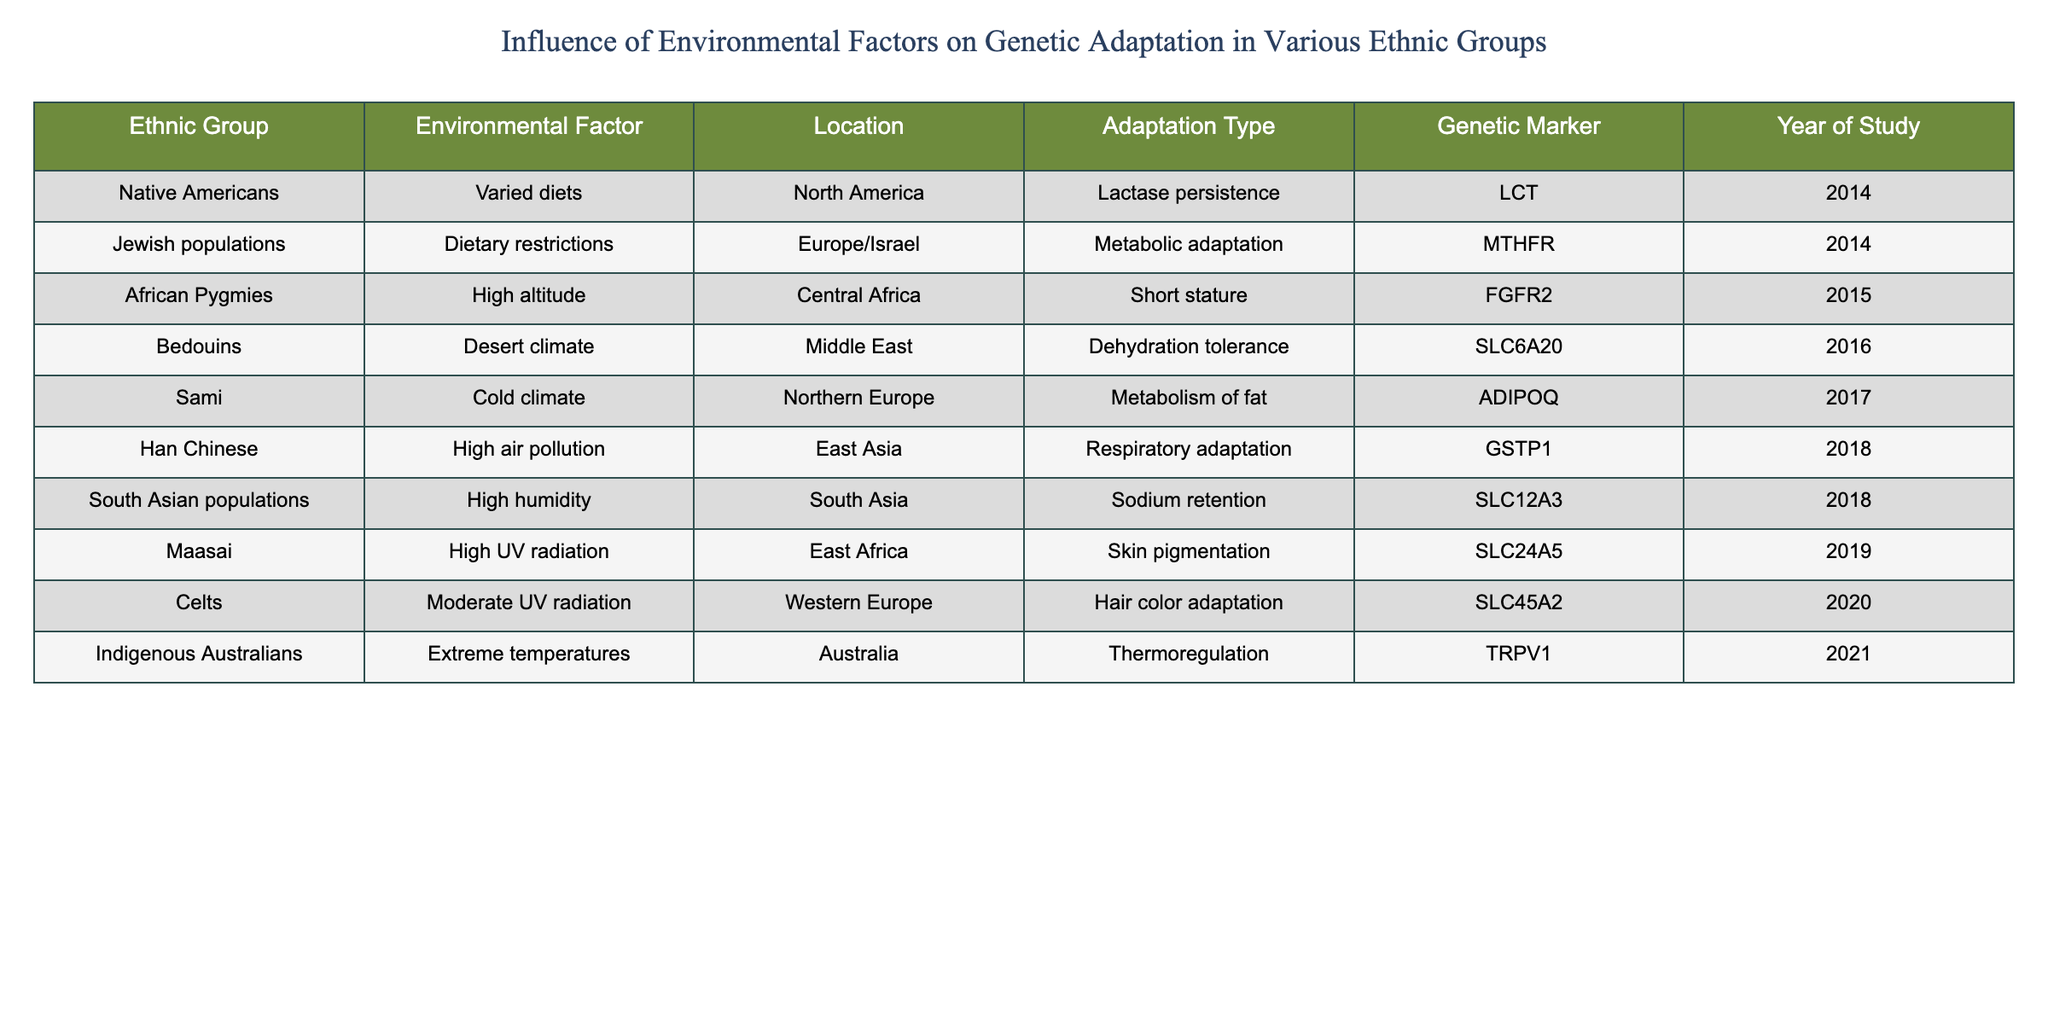What adaptation type is associated with African Pygmies? The table indicates that African Pygmies are associated with the adaptation type "Short stature." This information can be found in the row corresponding to the African Pygmies.
Answer: Short stature Which genetic marker is linked to the Sami? According to the table, the genetic marker linked to the Sami is "ADIPOQ." This is found in the row that describes the Sami and their adaptation to a cold climate.
Answer: ADIPOQ What is the year of study for the Han Chinese regarding respiratory adaptation? The year of study for the Han Chinese is "2018," as specified in the corresponding row for the high air pollution adaptation.
Answer: 2018 Are all the ethnic groups studied in a single continent? No, the data shows that ethnic groups are from various continents including Africa, Asia, Australia, Europe, and the Middle East, as evidenced by the locations listed in the table.
Answer: No What is the average year of study for the genetic adaptations? To find the average year of study, we first total the years: 2015 + 2017 + 2018 + 2016 + 2014 + 2019 + 2020 + 2014 + 2018 + 2021 = 2018. The total is divided by the number of studies (10), resulting in an average year of 2018.
Answer: 2018 Which adaptation type is associated with the Maasai? The table states that the adaptation type associated with the Maasai is "Skin pigmentation." This can be found in the row dedicated to the Maasai.
Answer: Skin pigmentation Do Bedouins exhibit metabolic adaptation due to their environmental factor? False, the Bedouins are associated with "Dehydration tolerance," not metabolic adaptation. This information can be confirmed by looking at the relevant row for Bedouins.
Answer: False What unique environmental condition do Indigenous Australians adapt to? Indigenous Australians are noted for their adaptation to "Extreme temperatures," as can be seen in their corresponding row.
Answer: Extreme temperatures Which ethnic group shows a high tolerance to dehydration, and what is their environmental factor? The Bedouins show a high tolerance to dehydration, which is attributed to their "Desert climate," noted in their respective row in the table.
Answer: Bedouins, Desert climate 